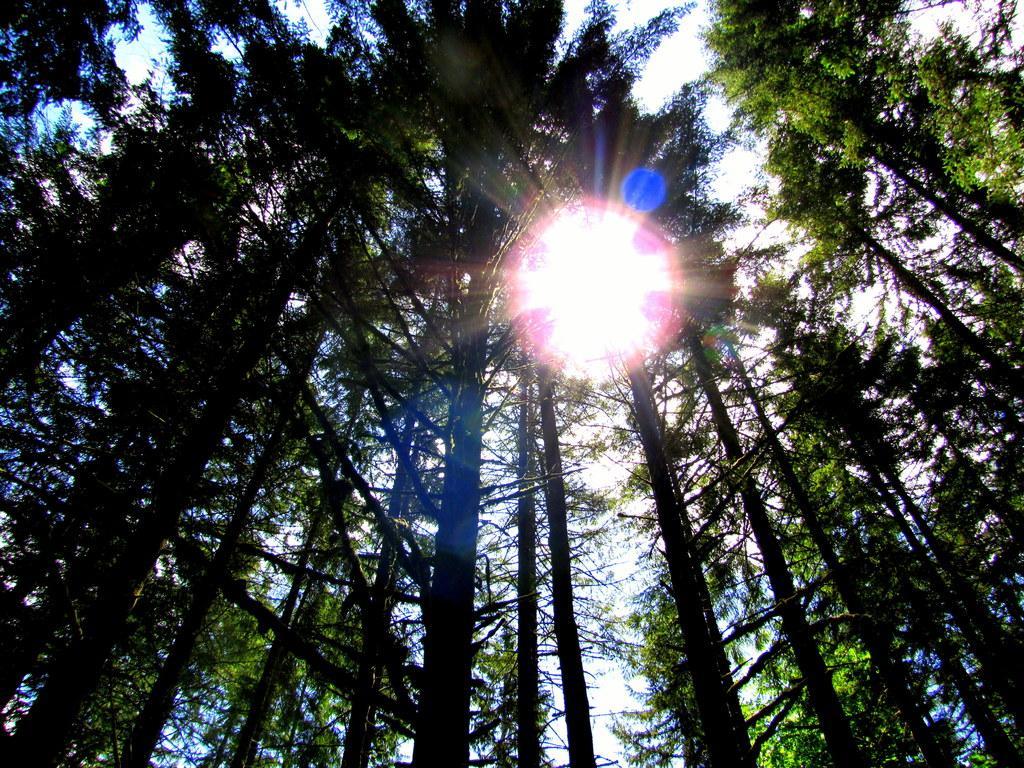How would you summarize this image in a sentence or two? In the image we can see there are many trees, white sky and the sun. 